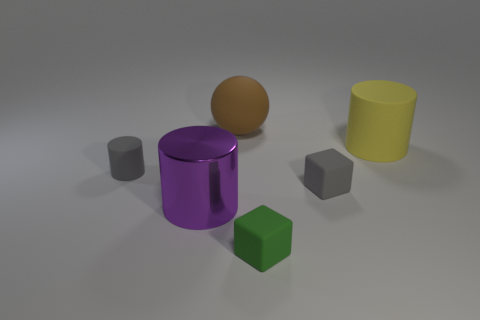The block that is the same color as the small matte cylinder is what size?
Provide a short and direct response. Small. What shape is the rubber thing that is the same color as the tiny cylinder?
Your response must be concise. Cube. What number of objects are either small matte objects that are to the right of the purple thing or large matte cylinders?
Make the answer very short. 3. What color is the small rubber object that is the same shape as the purple shiny thing?
Provide a short and direct response. Gray. Is there any other thing that is the same color as the large shiny cylinder?
Provide a short and direct response. No. How big is the brown rubber thing that is on the right side of the metal thing?
Ensure brevity in your answer.  Large. There is a tiny cylinder; is its color the same as the rubber block that is behind the big purple metallic object?
Your answer should be very brief. Yes. How many other objects are there of the same material as the tiny cylinder?
Keep it short and to the point. 4. Are there more rubber things than things?
Offer a terse response. No. There is a small matte cube behind the shiny thing; does it have the same color as the small cylinder?
Your answer should be very brief. Yes. 